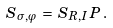Convert formula to latex. <formula><loc_0><loc_0><loc_500><loc_500>S _ { \sigma , \varphi } \, = \, S _ { R , I } \, P \, .</formula> 